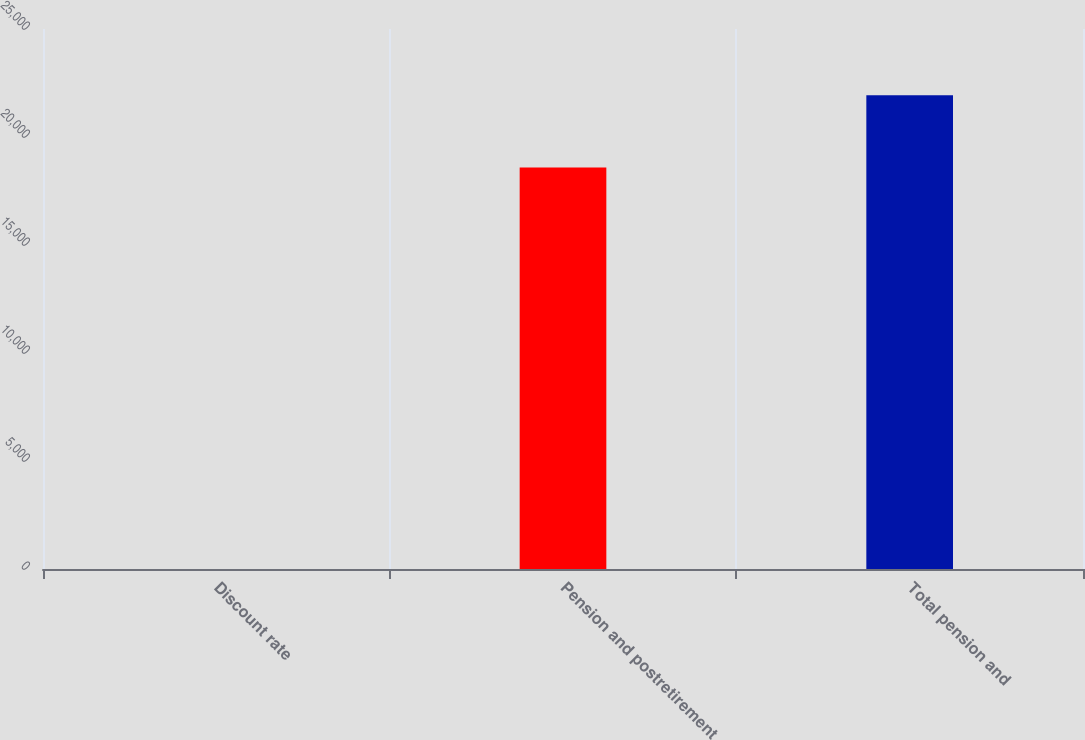Convert chart to OTSL. <chart><loc_0><loc_0><loc_500><loc_500><bar_chart><fcel>Discount rate<fcel>Pension and postretirement<fcel>Total pension and<nl><fcel>4<fcel>18587<fcel>21935<nl></chart> 